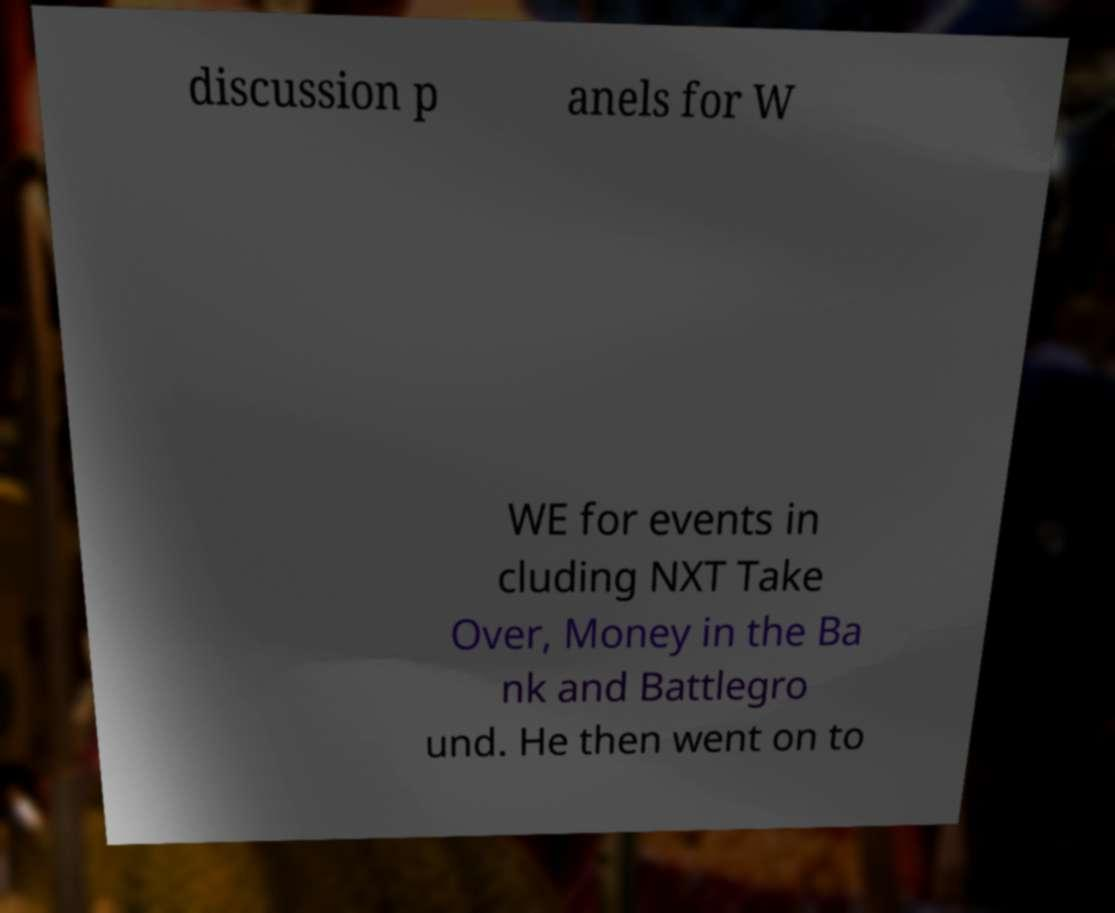Can you accurately transcribe the text from the provided image for me? discussion p anels for W WE for events in cluding NXT Take Over, Money in the Ba nk and Battlegro und. He then went on to 